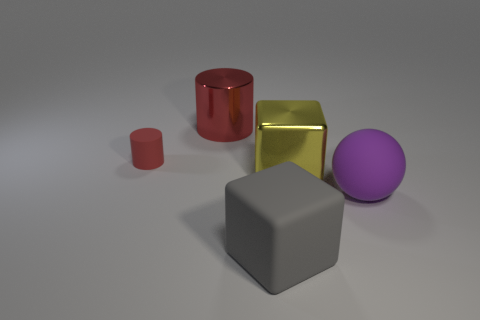Add 5 small yellow cylinders. How many objects exist? 10 Subtract all cylinders. How many objects are left? 3 Subtract 1 purple spheres. How many objects are left? 4 Subtract all rubber things. Subtract all metallic cubes. How many objects are left? 1 Add 3 small red rubber cylinders. How many small red rubber cylinders are left? 4 Add 1 red rubber blocks. How many red rubber blocks exist? 1 